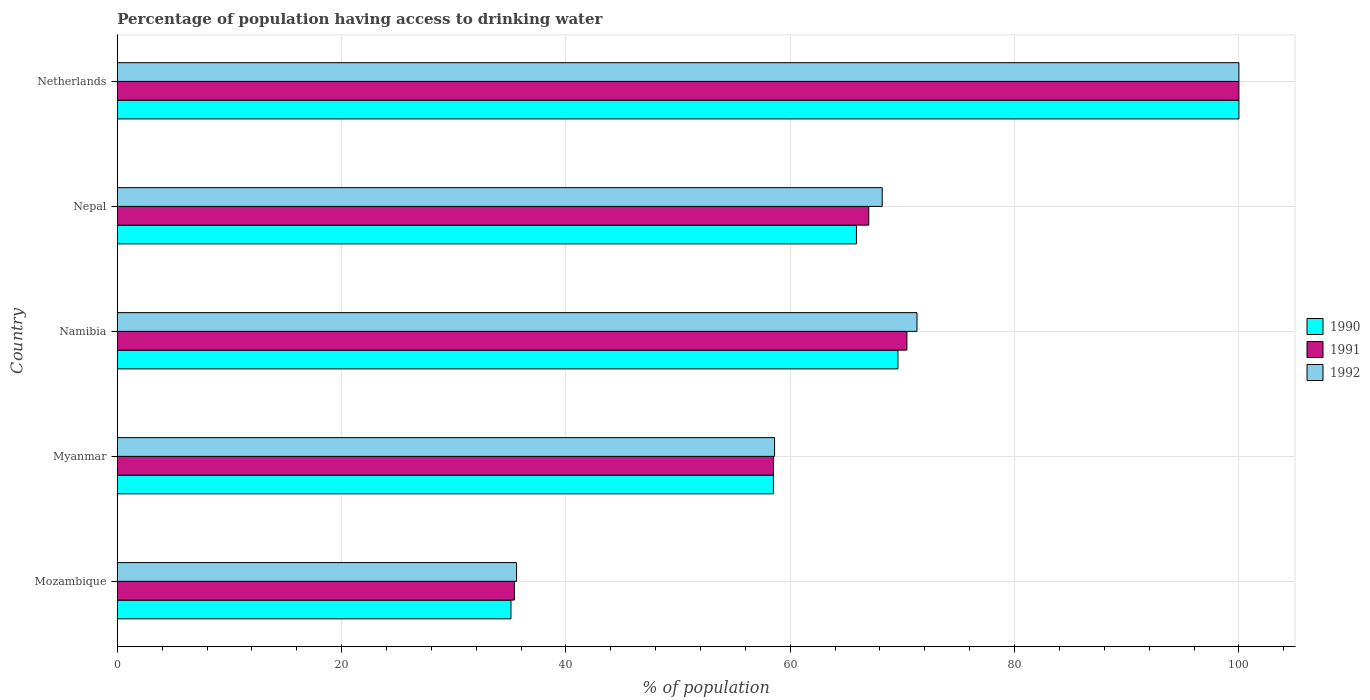How many different coloured bars are there?
Your response must be concise. 3. How many bars are there on the 2nd tick from the top?
Your response must be concise. 3. What is the label of the 4th group of bars from the top?
Ensure brevity in your answer.  Myanmar. In how many cases, is the number of bars for a given country not equal to the number of legend labels?
Provide a succinct answer. 0. What is the percentage of population having access to drinking water in 1991 in Nepal?
Your answer should be compact. 67. Across all countries, what is the maximum percentage of population having access to drinking water in 1991?
Keep it short and to the point. 100. Across all countries, what is the minimum percentage of population having access to drinking water in 1992?
Provide a succinct answer. 35.6. In which country was the percentage of population having access to drinking water in 1992 maximum?
Provide a short and direct response. Netherlands. In which country was the percentage of population having access to drinking water in 1990 minimum?
Keep it short and to the point. Mozambique. What is the total percentage of population having access to drinking water in 1991 in the graph?
Offer a very short reply. 331.3. What is the difference between the percentage of population having access to drinking water in 1992 in Myanmar and that in Nepal?
Offer a terse response. -9.6. What is the difference between the percentage of population having access to drinking water in 1992 in Netherlands and the percentage of population having access to drinking water in 1990 in Nepal?
Your answer should be very brief. 34.1. What is the average percentage of population having access to drinking water in 1992 per country?
Give a very brief answer. 66.74. What is the difference between the percentage of population having access to drinking water in 1992 and percentage of population having access to drinking water in 1991 in Nepal?
Keep it short and to the point. 1.2. In how many countries, is the percentage of population having access to drinking water in 1992 greater than 8 %?
Give a very brief answer. 5. What is the ratio of the percentage of population having access to drinking water in 1990 in Mozambique to that in Netherlands?
Your answer should be compact. 0.35. Is the percentage of population having access to drinking water in 1992 in Mozambique less than that in Myanmar?
Give a very brief answer. Yes. Is the difference between the percentage of population having access to drinking water in 1992 in Namibia and Netherlands greater than the difference between the percentage of population having access to drinking water in 1991 in Namibia and Netherlands?
Your answer should be very brief. Yes. What is the difference between the highest and the second highest percentage of population having access to drinking water in 1992?
Provide a short and direct response. 28.7. What is the difference between the highest and the lowest percentage of population having access to drinking water in 1991?
Keep it short and to the point. 64.6. In how many countries, is the percentage of population having access to drinking water in 1990 greater than the average percentage of population having access to drinking water in 1990 taken over all countries?
Provide a succinct answer. 3. Is it the case that in every country, the sum of the percentage of population having access to drinking water in 1992 and percentage of population having access to drinking water in 1991 is greater than the percentage of population having access to drinking water in 1990?
Provide a succinct answer. Yes. Are all the bars in the graph horizontal?
Provide a succinct answer. Yes. How many countries are there in the graph?
Your answer should be very brief. 5. Are the values on the major ticks of X-axis written in scientific E-notation?
Provide a short and direct response. No. Does the graph contain any zero values?
Provide a short and direct response. No. Does the graph contain grids?
Your answer should be compact. Yes. Where does the legend appear in the graph?
Make the answer very short. Center right. How many legend labels are there?
Make the answer very short. 3. What is the title of the graph?
Your response must be concise. Percentage of population having access to drinking water. What is the label or title of the X-axis?
Keep it short and to the point. % of population. What is the % of population in 1990 in Mozambique?
Offer a terse response. 35.1. What is the % of population in 1991 in Mozambique?
Make the answer very short. 35.4. What is the % of population of 1992 in Mozambique?
Give a very brief answer. 35.6. What is the % of population in 1990 in Myanmar?
Provide a succinct answer. 58.5. What is the % of population in 1991 in Myanmar?
Provide a succinct answer. 58.5. What is the % of population of 1992 in Myanmar?
Ensure brevity in your answer.  58.6. What is the % of population of 1990 in Namibia?
Offer a very short reply. 69.6. What is the % of population in 1991 in Namibia?
Make the answer very short. 70.4. What is the % of population in 1992 in Namibia?
Offer a terse response. 71.3. What is the % of population in 1990 in Nepal?
Make the answer very short. 65.9. What is the % of population of 1992 in Nepal?
Make the answer very short. 68.2. What is the % of population in 1990 in Netherlands?
Provide a succinct answer. 100. What is the % of population of 1991 in Netherlands?
Keep it short and to the point. 100. Across all countries, what is the maximum % of population in 1992?
Provide a short and direct response. 100. Across all countries, what is the minimum % of population of 1990?
Provide a short and direct response. 35.1. Across all countries, what is the minimum % of population of 1991?
Offer a very short reply. 35.4. Across all countries, what is the minimum % of population of 1992?
Provide a succinct answer. 35.6. What is the total % of population in 1990 in the graph?
Give a very brief answer. 329.1. What is the total % of population in 1991 in the graph?
Offer a very short reply. 331.3. What is the total % of population of 1992 in the graph?
Provide a succinct answer. 333.7. What is the difference between the % of population in 1990 in Mozambique and that in Myanmar?
Your answer should be compact. -23.4. What is the difference between the % of population in 1991 in Mozambique and that in Myanmar?
Your answer should be compact. -23.1. What is the difference between the % of population of 1990 in Mozambique and that in Namibia?
Your answer should be very brief. -34.5. What is the difference between the % of population in 1991 in Mozambique and that in Namibia?
Your response must be concise. -35. What is the difference between the % of population of 1992 in Mozambique and that in Namibia?
Offer a terse response. -35.7. What is the difference between the % of population in 1990 in Mozambique and that in Nepal?
Give a very brief answer. -30.8. What is the difference between the % of population of 1991 in Mozambique and that in Nepal?
Ensure brevity in your answer.  -31.6. What is the difference between the % of population in 1992 in Mozambique and that in Nepal?
Give a very brief answer. -32.6. What is the difference between the % of population in 1990 in Mozambique and that in Netherlands?
Offer a very short reply. -64.9. What is the difference between the % of population of 1991 in Mozambique and that in Netherlands?
Give a very brief answer. -64.6. What is the difference between the % of population in 1992 in Mozambique and that in Netherlands?
Your answer should be compact. -64.4. What is the difference between the % of population in 1990 in Myanmar and that in Namibia?
Keep it short and to the point. -11.1. What is the difference between the % of population in 1991 in Myanmar and that in Namibia?
Your answer should be very brief. -11.9. What is the difference between the % of population in 1992 in Myanmar and that in Namibia?
Keep it short and to the point. -12.7. What is the difference between the % of population in 1990 in Myanmar and that in Nepal?
Keep it short and to the point. -7.4. What is the difference between the % of population in 1990 in Myanmar and that in Netherlands?
Provide a succinct answer. -41.5. What is the difference between the % of population of 1991 in Myanmar and that in Netherlands?
Provide a short and direct response. -41.5. What is the difference between the % of population of 1992 in Myanmar and that in Netherlands?
Offer a terse response. -41.4. What is the difference between the % of population of 1990 in Namibia and that in Netherlands?
Give a very brief answer. -30.4. What is the difference between the % of population in 1991 in Namibia and that in Netherlands?
Provide a short and direct response. -29.6. What is the difference between the % of population of 1992 in Namibia and that in Netherlands?
Your response must be concise. -28.7. What is the difference between the % of population of 1990 in Nepal and that in Netherlands?
Offer a terse response. -34.1. What is the difference between the % of population of 1991 in Nepal and that in Netherlands?
Provide a short and direct response. -33. What is the difference between the % of population of 1992 in Nepal and that in Netherlands?
Keep it short and to the point. -31.8. What is the difference between the % of population of 1990 in Mozambique and the % of population of 1991 in Myanmar?
Your response must be concise. -23.4. What is the difference between the % of population in 1990 in Mozambique and the % of population in 1992 in Myanmar?
Give a very brief answer. -23.5. What is the difference between the % of population of 1991 in Mozambique and the % of population of 1992 in Myanmar?
Your answer should be very brief. -23.2. What is the difference between the % of population in 1990 in Mozambique and the % of population in 1991 in Namibia?
Keep it short and to the point. -35.3. What is the difference between the % of population of 1990 in Mozambique and the % of population of 1992 in Namibia?
Ensure brevity in your answer.  -36.2. What is the difference between the % of population in 1991 in Mozambique and the % of population in 1992 in Namibia?
Provide a succinct answer. -35.9. What is the difference between the % of population in 1990 in Mozambique and the % of population in 1991 in Nepal?
Give a very brief answer. -31.9. What is the difference between the % of population of 1990 in Mozambique and the % of population of 1992 in Nepal?
Your answer should be very brief. -33.1. What is the difference between the % of population of 1991 in Mozambique and the % of population of 1992 in Nepal?
Your answer should be very brief. -32.8. What is the difference between the % of population of 1990 in Mozambique and the % of population of 1991 in Netherlands?
Your response must be concise. -64.9. What is the difference between the % of population of 1990 in Mozambique and the % of population of 1992 in Netherlands?
Provide a succinct answer. -64.9. What is the difference between the % of population in 1991 in Mozambique and the % of population in 1992 in Netherlands?
Provide a succinct answer. -64.6. What is the difference between the % of population in 1991 in Myanmar and the % of population in 1992 in Nepal?
Give a very brief answer. -9.7. What is the difference between the % of population of 1990 in Myanmar and the % of population of 1991 in Netherlands?
Provide a succinct answer. -41.5. What is the difference between the % of population of 1990 in Myanmar and the % of population of 1992 in Netherlands?
Make the answer very short. -41.5. What is the difference between the % of population of 1991 in Myanmar and the % of population of 1992 in Netherlands?
Offer a very short reply. -41.5. What is the difference between the % of population in 1990 in Namibia and the % of population in 1992 in Nepal?
Ensure brevity in your answer.  1.4. What is the difference between the % of population in 1991 in Namibia and the % of population in 1992 in Nepal?
Provide a succinct answer. 2.2. What is the difference between the % of population of 1990 in Namibia and the % of population of 1991 in Netherlands?
Provide a succinct answer. -30.4. What is the difference between the % of population of 1990 in Namibia and the % of population of 1992 in Netherlands?
Your answer should be very brief. -30.4. What is the difference between the % of population in 1991 in Namibia and the % of population in 1992 in Netherlands?
Your response must be concise. -29.6. What is the difference between the % of population of 1990 in Nepal and the % of population of 1991 in Netherlands?
Your response must be concise. -34.1. What is the difference between the % of population in 1990 in Nepal and the % of population in 1992 in Netherlands?
Offer a very short reply. -34.1. What is the difference between the % of population of 1991 in Nepal and the % of population of 1992 in Netherlands?
Provide a succinct answer. -33. What is the average % of population in 1990 per country?
Provide a short and direct response. 65.82. What is the average % of population in 1991 per country?
Your answer should be very brief. 66.26. What is the average % of population of 1992 per country?
Give a very brief answer. 66.74. What is the difference between the % of population of 1990 and % of population of 1991 in Mozambique?
Ensure brevity in your answer.  -0.3. What is the difference between the % of population of 1990 and % of population of 1992 in Mozambique?
Your response must be concise. -0.5. What is the difference between the % of population of 1991 and % of population of 1992 in Mozambique?
Give a very brief answer. -0.2. What is the difference between the % of population in 1990 and % of population in 1992 in Myanmar?
Your answer should be very brief. -0.1. What is the difference between the % of population in 1990 and % of population in 1991 in Namibia?
Keep it short and to the point. -0.8. What is the difference between the % of population of 1990 and % of population of 1992 in Namibia?
Provide a short and direct response. -1.7. What is the difference between the % of population of 1991 and % of population of 1992 in Namibia?
Your answer should be very brief. -0.9. What is the difference between the % of population in 1990 and % of population in 1992 in Nepal?
Provide a succinct answer. -2.3. What is the difference between the % of population of 1990 and % of population of 1992 in Netherlands?
Your answer should be compact. 0. What is the ratio of the % of population of 1990 in Mozambique to that in Myanmar?
Offer a very short reply. 0.6. What is the ratio of the % of population of 1991 in Mozambique to that in Myanmar?
Your answer should be very brief. 0.61. What is the ratio of the % of population of 1992 in Mozambique to that in Myanmar?
Your answer should be compact. 0.61. What is the ratio of the % of population of 1990 in Mozambique to that in Namibia?
Offer a very short reply. 0.5. What is the ratio of the % of population in 1991 in Mozambique to that in Namibia?
Provide a short and direct response. 0.5. What is the ratio of the % of population in 1992 in Mozambique to that in Namibia?
Make the answer very short. 0.5. What is the ratio of the % of population in 1990 in Mozambique to that in Nepal?
Give a very brief answer. 0.53. What is the ratio of the % of population of 1991 in Mozambique to that in Nepal?
Ensure brevity in your answer.  0.53. What is the ratio of the % of population of 1992 in Mozambique to that in Nepal?
Provide a succinct answer. 0.52. What is the ratio of the % of population of 1990 in Mozambique to that in Netherlands?
Ensure brevity in your answer.  0.35. What is the ratio of the % of population in 1991 in Mozambique to that in Netherlands?
Your answer should be compact. 0.35. What is the ratio of the % of population in 1992 in Mozambique to that in Netherlands?
Ensure brevity in your answer.  0.36. What is the ratio of the % of population in 1990 in Myanmar to that in Namibia?
Make the answer very short. 0.84. What is the ratio of the % of population in 1991 in Myanmar to that in Namibia?
Provide a short and direct response. 0.83. What is the ratio of the % of population of 1992 in Myanmar to that in Namibia?
Give a very brief answer. 0.82. What is the ratio of the % of population in 1990 in Myanmar to that in Nepal?
Your response must be concise. 0.89. What is the ratio of the % of population in 1991 in Myanmar to that in Nepal?
Your response must be concise. 0.87. What is the ratio of the % of population of 1992 in Myanmar to that in Nepal?
Ensure brevity in your answer.  0.86. What is the ratio of the % of population in 1990 in Myanmar to that in Netherlands?
Your answer should be very brief. 0.58. What is the ratio of the % of population in 1991 in Myanmar to that in Netherlands?
Offer a terse response. 0.58. What is the ratio of the % of population in 1992 in Myanmar to that in Netherlands?
Provide a short and direct response. 0.59. What is the ratio of the % of population in 1990 in Namibia to that in Nepal?
Give a very brief answer. 1.06. What is the ratio of the % of population of 1991 in Namibia to that in Nepal?
Keep it short and to the point. 1.05. What is the ratio of the % of population of 1992 in Namibia to that in Nepal?
Ensure brevity in your answer.  1.05. What is the ratio of the % of population in 1990 in Namibia to that in Netherlands?
Offer a very short reply. 0.7. What is the ratio of the % of population in 1991 in Namibia to that in Netherlands?
Your answer should be compact. 0.7. What is the ratio of the % of population in 1992 in Namibia to that in Netherlands?
Offer a very short reply. 0.71. What is the ratio of the % of population in 1990 in Nepal to that in Netherlands?
Provide a succinct answer. 0.66. What is the ratio of the % of population in 1991 in Nepal to that in Netherlands?
Provide a succinct answer. 0.67. What is the ratio of the % of population of 1992 in Nepal to that in Netherlands?
Your response must be concise. 0.68. What is the difference between the highest and the second highest % of population of 1990?
Your response must be concise. 30.4. What is the difference between the highest and the second highest % of population in 1991?
Offer a very short reply. 29.6. What is the difference between the highest and the second highest % of population of 1992?
Give a very brief answer. 28.7. What is the difference between the highest and the lowest % of population in 1990?
Ensure brevity in your answer.  64.9. What is the difference between the highest and the lowest % of population of 1991?
Your response must be concise. 64.6. What is the difference between the highest and the lowest % of population in 1992?
Your response must be concise. 64.4. 